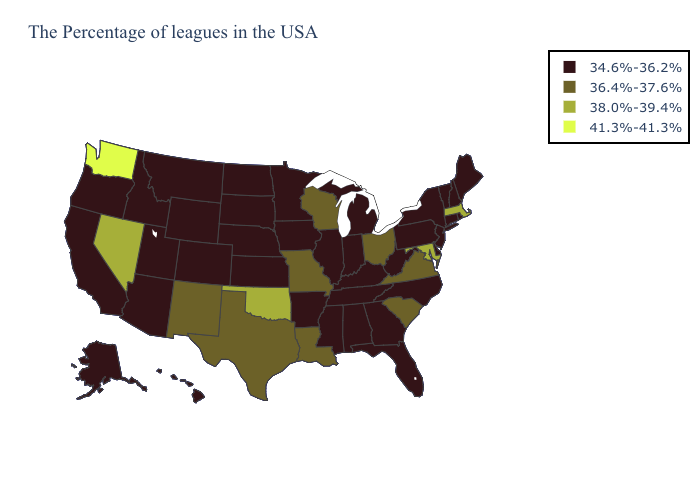What is the value of Montana?
Quick response, please. 34.6%-36.2%. What is the value of Idaho?
Keep it brief. 34.6%-36.2%. Among the states that border Indiana , does Ohio have the highest value?
Concise answer only. Yes. What is the highest value in the USA?
Answer briefly. 41.3%-41.3%. Which states have the highest value in the USA?
Concise answer only. Washington. Does California have the highest value in the West?
Give a very brief answer. No. What is the value of Tennessee?
Write a very short answer. 34.6%-36.2%. Which states have the highest value in the USA?
Concise answer only. Washington. Does South Carolina have a lower value than Maryland?
Short answer required. Yes. Does New York have the same value as Indiana?
Give a very brief answer. Yes. Does Missouri have the lowest value in the USA?
Write a very short answer. No. Name the states that have a value in the range 36.4%-37.6%?
Be succinct. Virginia, South Carolina, Ohio, Wisconsin, Louisiana, Missouri, Texas, New Mexico. Name the states that have a value in the range 41.3%-41.3%?
Short answer required. Washington. Does the first symbol in the legend represent the smallest category?
Be succinct. Yes. 